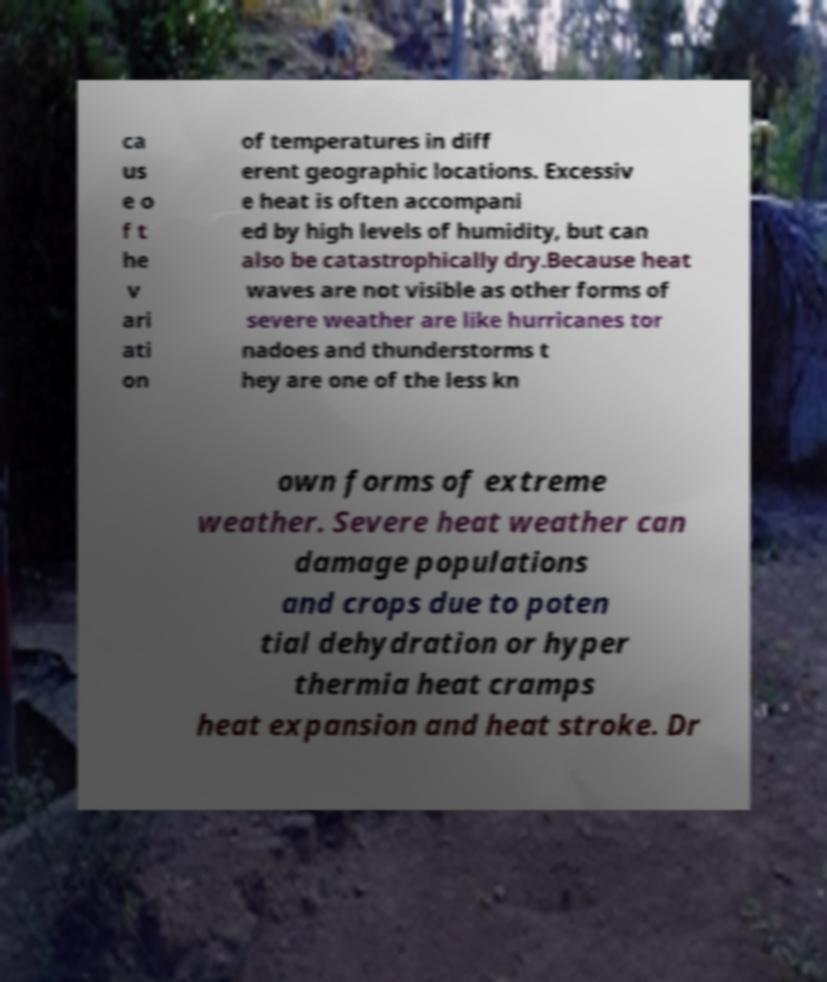For documentation purposes, I need the text within this image transcribed. Could you provide that? ca us e o f t he v ari ati on of temperatures in diff erent geographic locations. Excessiv e heat is often accompani ed by high levels of humidity, but can also be catastrophically dry.Because heat waves are not visible as other forms of severe weather are like hurricanes tor nadoes and thunderstorms t hey are one of the less kn own forms of extreme weather. Severe heat weather can damage populations and crops due to poten tial dehydration or hyper thermia heat cramps heat expansion and heat stroke. Dr 